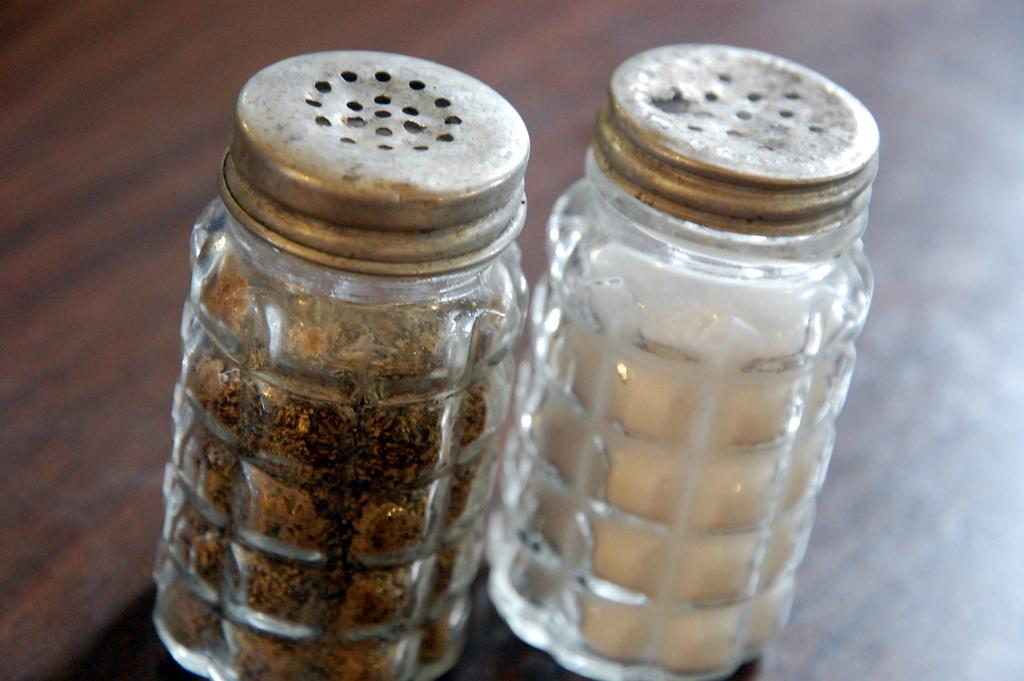What objects are present in the image? There are two glass bottles in the image. What is the surface on which the bottles are placed? The bottles are on a wooden surface. What can be found inside the bottles? There are food items inside the bottles that resemble salt and pepper. What type of marble is visible in the image? There is no marble present in the image; it features two glass bottles with food items inside. 